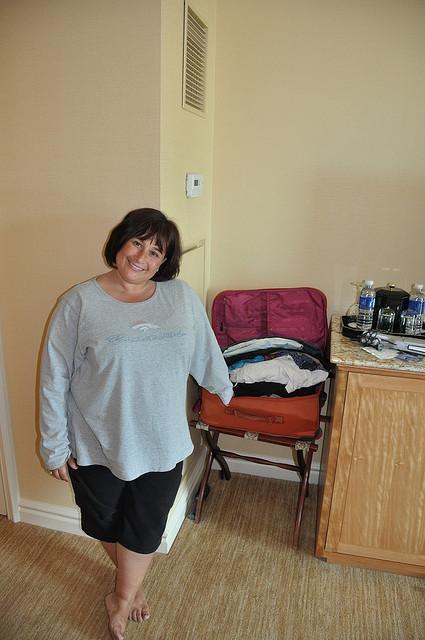How many people are there?
Give a very brief answer. 1. 